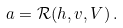Convert formula to latex. <formula><loc_0><loc_0><loc_500><loc_500>a = \mathcal { R } ( h , v , V ) \, .</formula> 